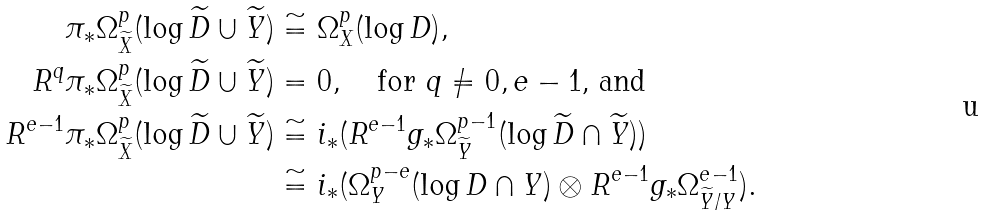<formula> <loc_0><loc_0><loc_500><loc_500>\pi _ { \ast } \Omega ^ { p } _ { \widetilde { X } } ( \log \widetilde { D } \cup \widetilde { Y } ) & \cong \Omega ^ { p } _ { X } ( \log D ) , \\ R ^ { q } \pi _ { \ast } \Omega ^ { p } _ { \widetilde { X } } ( \log \widetilde { D } \cup \widetilde { Y } ) & = 0 , \quad \text {for $q\not=0,e-1$, and} \\ R ^ { e - 1 } \pi _ { \ast } \Omega ^ { p } _ { \widetilde { X } } ( \log \widetilde { D } \cup \widetilde { Y } ) & \cong i _ { \ast } ( R ^ { e - 1 } g _ { \ast } \Omega ^ { p - 1 } _ { \widetilde { Y } } ( \log \widetilde { D } \cap \widetilde { Y } ) ) \\ & \cong i _ { \ast } ( \Omega ^ { p - e } _ { Y } ( \log D \cap Y ) \otimes R ^ { e - 1 } g _ { \ast } \Omega ^ { e - 1 } _ { \widetilde { Y } / Y } ) .</formula> 